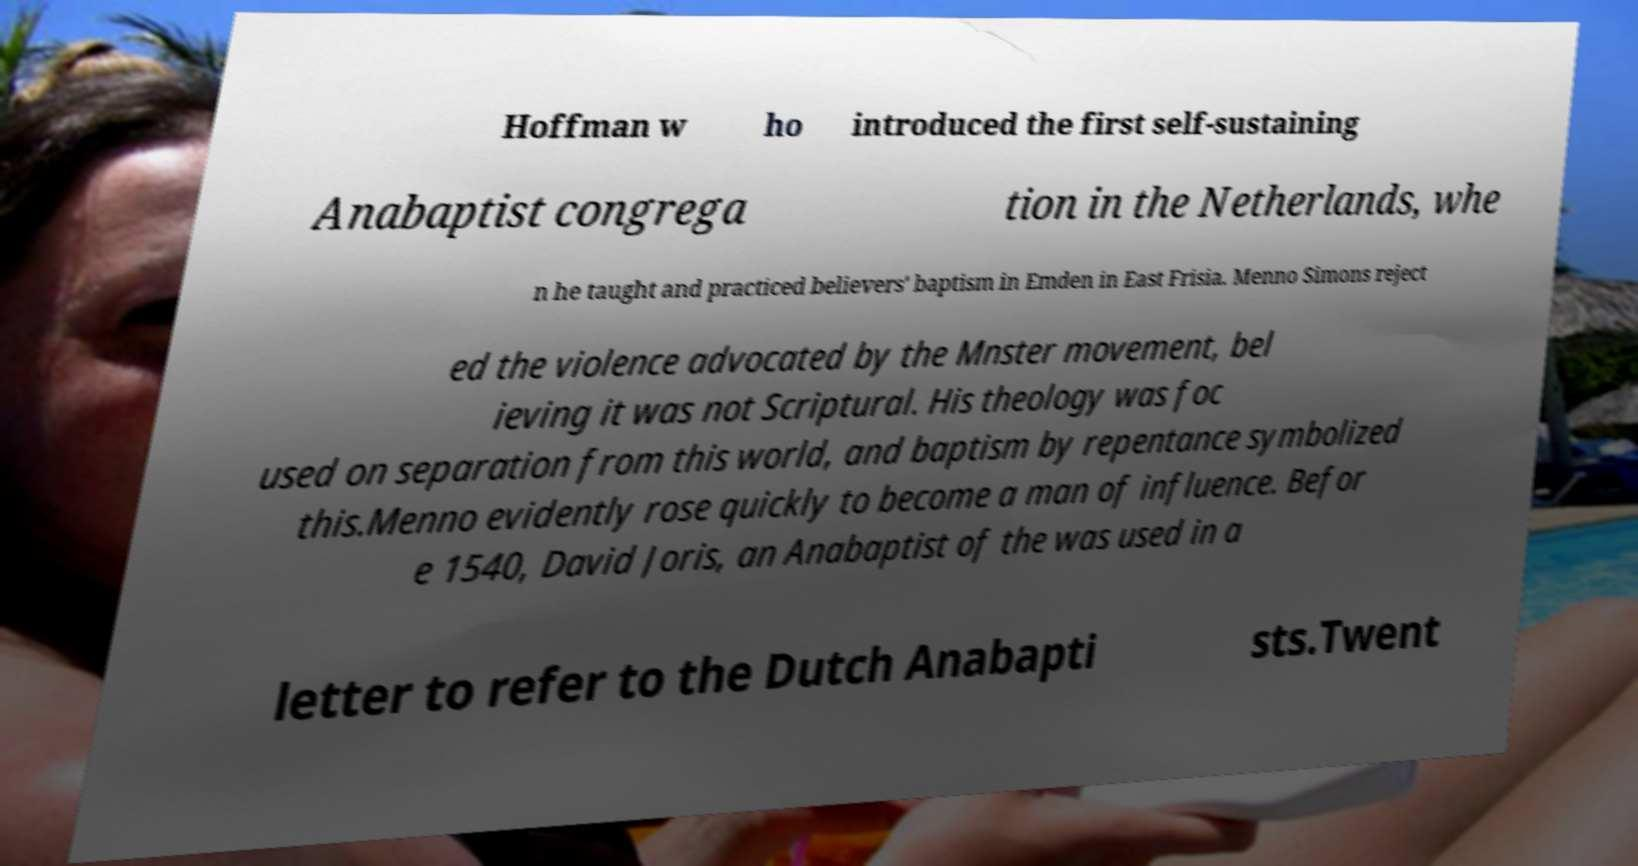What messages or text are displayed in this image? I need them in a readable, typed format. Hoffman w ho introduced the first self-sustaining Anabaptist congrega tion in the Netherlands, whe n he taught and practiced believers' baptism in Emden in East Frisia. Menno Simons reject ed the violence advocated by the Mnster movement, bel ieving it was not Scriptural. His theology was foc used on separation from this world, and baptism by repentance symbolized this.Menno evidently rose quickly to become a man of influence. Befor e 1540, David Joris, an Anabaptist of the was used in a letter to refer to the Dutch Anabapti sts.Twent 